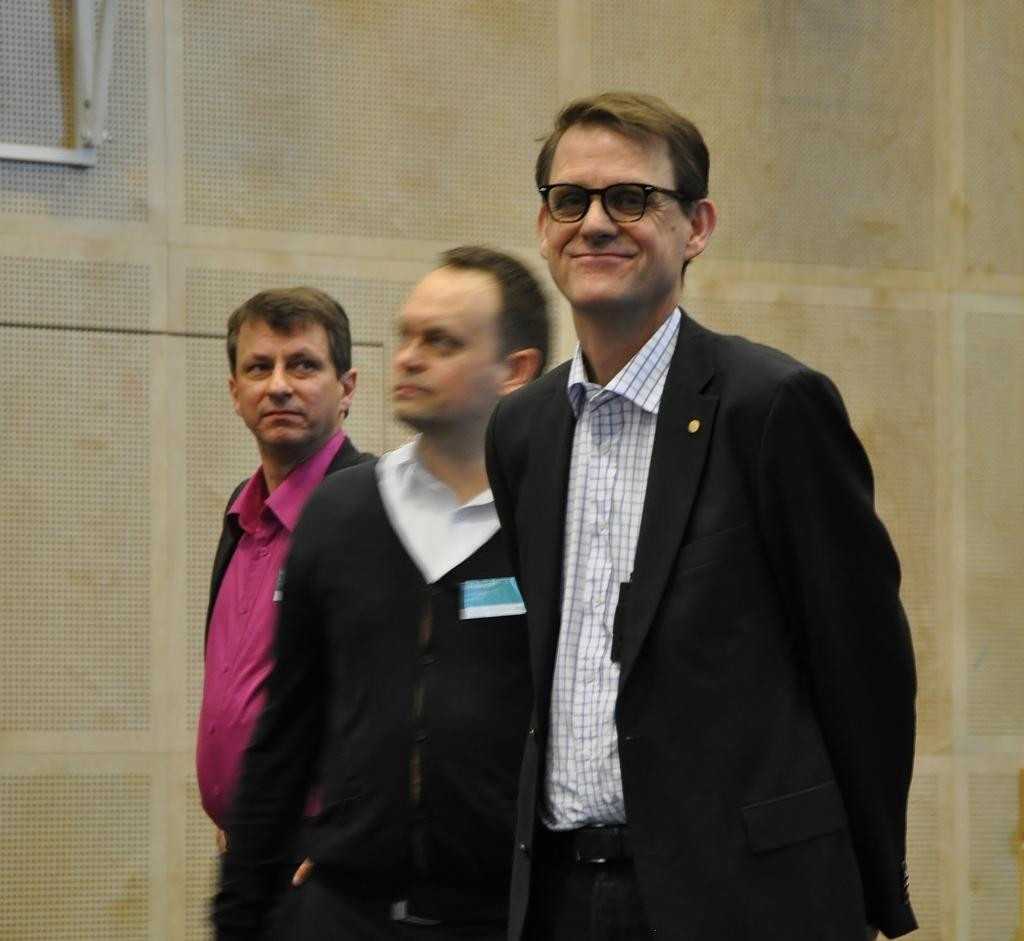What type of image is being described? The image is animated. How many men are present in the image? There are three men standing in the middle of the image. What can be seen in the background of the image? There is a white color wall in the background of the image. What type of ink is being used by the men in the image? There is no ink present in the image, as it is an animated scene with no visible writing or drawing tools. 